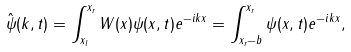Convert formula to latex. <formula><loc_0><loc_0><loc_500><loc_500>\hat { \psi } ( k , t ) = \int _ { x _ { l } } ^ { x _ { r } } W ( x ) \psi ( x , t ) e ^ { - i k x } = \int _ { x _ { r } - b } ^ { x _ { r } } \psi ( x , t ) e ^ { - i k x } ,</formula> 